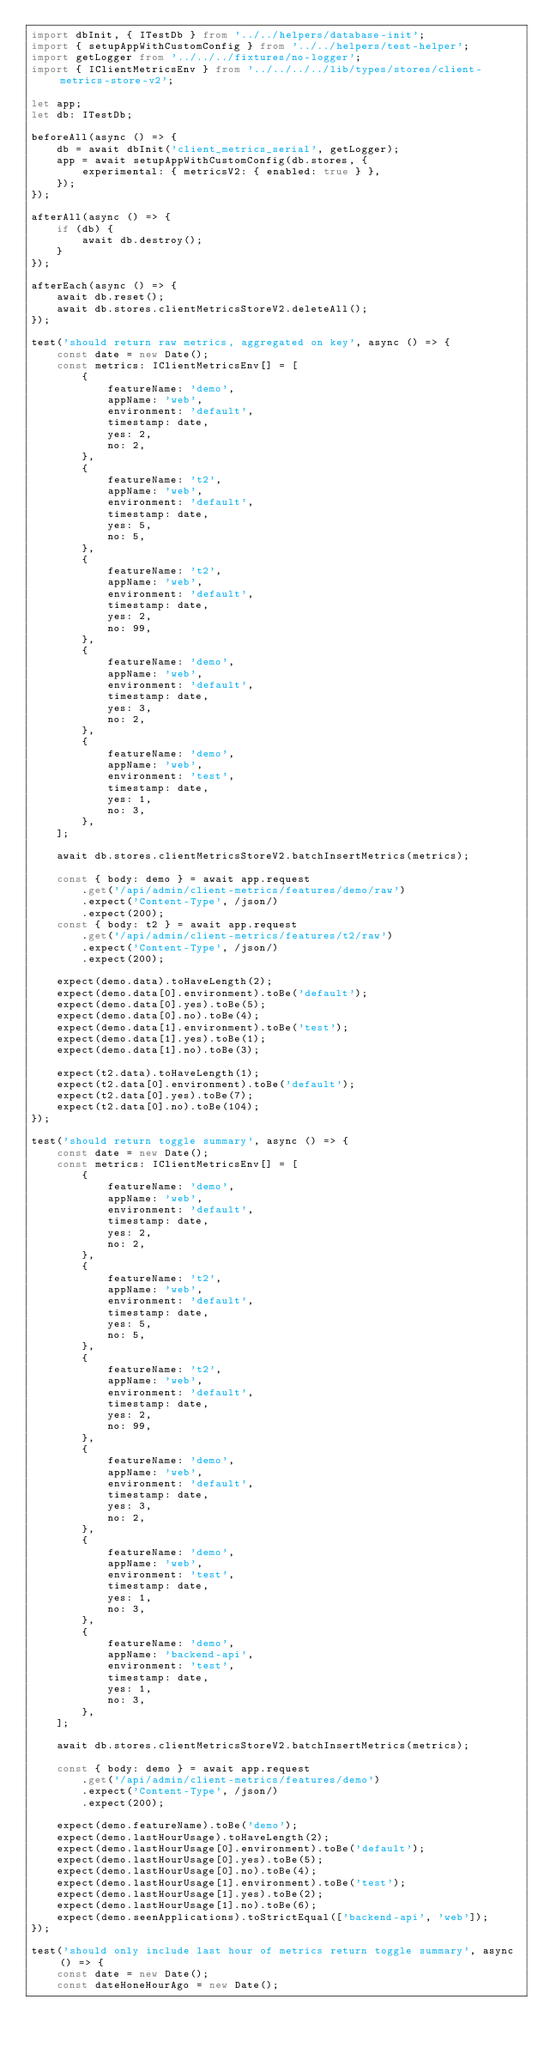Convert code to text. <code><loc_0><loc_0><loc_500><loc_500><_TypeScript_>import dbInit, { ITestDb } from '../../helpers/database-init';
import { setupAppWithCustomConfig } from '../../helpers/test-helper';
import getLogger from '../../../fixtures/no-logger';
import { IClientMetricsEnv } from '../../../../lib/types/stores/client-metrics-store-v2';

let app;
let db: ITestDb;

beforeAll(async () => {
    db = await dbInit('client_metrics_serial', getLogger);
    app = await setupAppWithCustomConfig(db.stores, {
        experimental: { metricsV2: { enabled: true } },
    });
});

afterAll(async () => {
    if (db) {
        await db.destroy();
    }
});

afterEach(async () => {
    await db.reset();
    await db.stores.clientMetricsStoreV2.deleteAll();
});

test('should return raw metrics, aggregated on key', async () => {
    const date = new Date();
    const metrics: IClientMetricsEnv[] = [
        {
            featureName: 'demo',
            appName: 'web',
            environment: 'default',
            timestamp: date,
            yes: 2,
            no: 2,
        },
        {
            featureName: 't2',
            appName: 'web',
            environment: 'default',
            timestamp: date,
            yes: 5,
            no: 5,
        },
        {
            featureName: 't2',
            appName: 'web',
            environment: 'default',
            timestamp: date,
            yes: 2,
            no: 99,
        },
        {
            featureName: 'demo',
            appName: 'web',
            environment: 'default',
            timestamp: date,
            yes: 3,
            no: 2,
        },
        {
            featureName: 'demo',
            appName: 'web',
            environment: 'test',
            timestamp: date,
            yes: 1,
            no: 3,
        },
    ];

    await db.stores.clientMetricsStoreV2.batchInsertMetrics(metrics);

    const { body: demo } = await app.request
        .get('/api/admin/client-metrics/features/demo/raw')
        .expect('Content-Type', /json/)
        .expect(200);
    const { body: t2 } = await app.request
        .get('/api/admin/client-metrics/features/t2/raw')
        .expect('Content-Type', /json/)
        .expect(200);

    expect(demo.data).toHaveLength(2);
    expect(demo.data[0].environment).toBe('default');
    expect(demo.data[0].yes).toBe(5);
    expect(demo.data[0].no).toBe(4);
    expect(demo.data[1].environment).toBe('test');
    expect(demo.data[1].yes).toBe(1);
    expect(demo.data[1].no).toBe(3);

    expect(t2.data).toHaveLength(1);
    expect(t2.data[0].environment).toBe('default');
    expect(t2.data[0].yes).toBe(7);
    expect(t2.data[0].no).toBe(104);
});

test('should return toggle summary', async () => {
    const date = new Date();
    const metrics: IClientMetricsEnv[] = [
        {
            featureName: 'demo',
            appName: 'web',
            environment: 'default',
            timestamp: date,
            yes: 2,
            no: 2,
        },
        {
            featureName: 't2',
            appName: 'web',
            environment: 'default',
            timestamp: date,
            yes: 5,
            no: 5,
        },
        {
            featureName: 't2',
            appName: 'web',
            environment: 'default',
            timestamp: date,
            yes: 2,
            no: 99,
        },
        {
            featureName: 'demo',
            appName: 'web',
            environment: 'default',
            timestamp: date,
            yes: 3,
            no: 2,
        },
        {
            featureName: 'demo',
            appName: 'web',
            environment: 'test',
            timestamp: date,
            yes: 1,
            no: 3,
        },
        {
            featureName: 'demo',
            appName: 'backend-api',
            environment: 'test',
            timestamp: date,
            yes: 1,
            no: 3,
        },
    ];

    await db.stores.clientMetricsStoreV2.batchInsertMetrics(metrics);

    const { body: demo } = await app.request
        .get('/api/admin/client-metrics/features/demo')
        .expect('Content-Type', /json/)
        .expect(200);

    expect(demo.featureName).toBe('demo');
    expect(demo.lastHourUsage).toHaveLength(2);
    expect(demo.lastHourUsage[0].environment).toBe('default');
    expect(demo.lastHourUsage[0].yes).toBe(5);
    expect(demo.lastHourUsage[0].no).toBe(4);
    expect(demo.lastHourUsage[1].environment).toBe('test');
    expect(demo.lastHourUsage[1].yes).toBe(2);
    expect(demo.lastHourUsage[1].no).toBe(6);
    expect(demo.seenApplications).toStrictEqual(['backend-api', 'web']);
});

test('should only include last hour of metrics return toggle summary', async () => {
    const date = new Date();
    const dateHoneHourAgo = new Date();</code> 